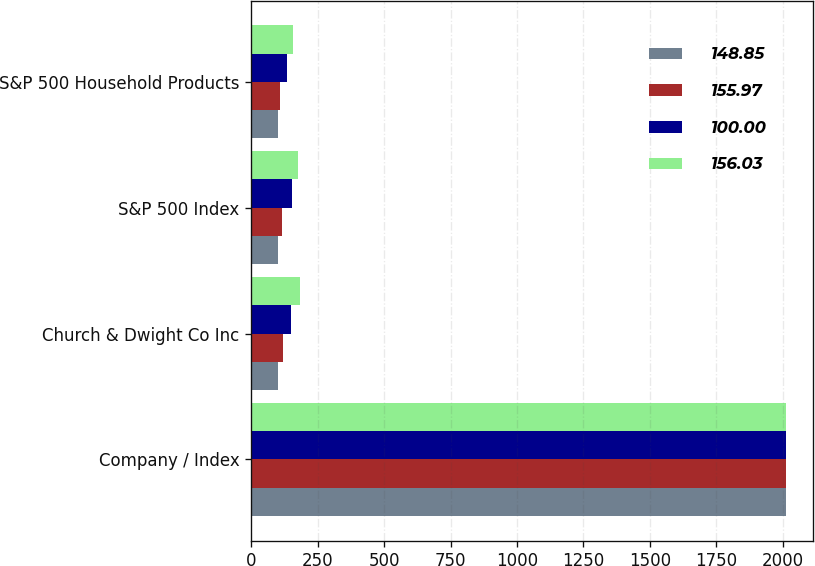Convert chart to OTSL. <chart><loc_0><loc_0><loc_500><loc_500><stacked_bar_chart><ecel><fcel>Company / Index<fcel>Church & Dwight Co Inc<fcel>S&P 500 Index<fcel>S&P 500 Household Products<nl><fcel>148.85<fcel>2011<fcel>100<fcel>100<fcel>100<nl><fcel>155.97<fcel>2012<fcel>119.29<fcel>116<fcel>108.77<nl><fcel>100<fcel>2013<fcel>150.26<fcel>153.56<fcel>136.04<nl><fcel>156.03<fcel>2014<fcel>181.96<fcel>174.57<fcel>155.97<nl></chart> 